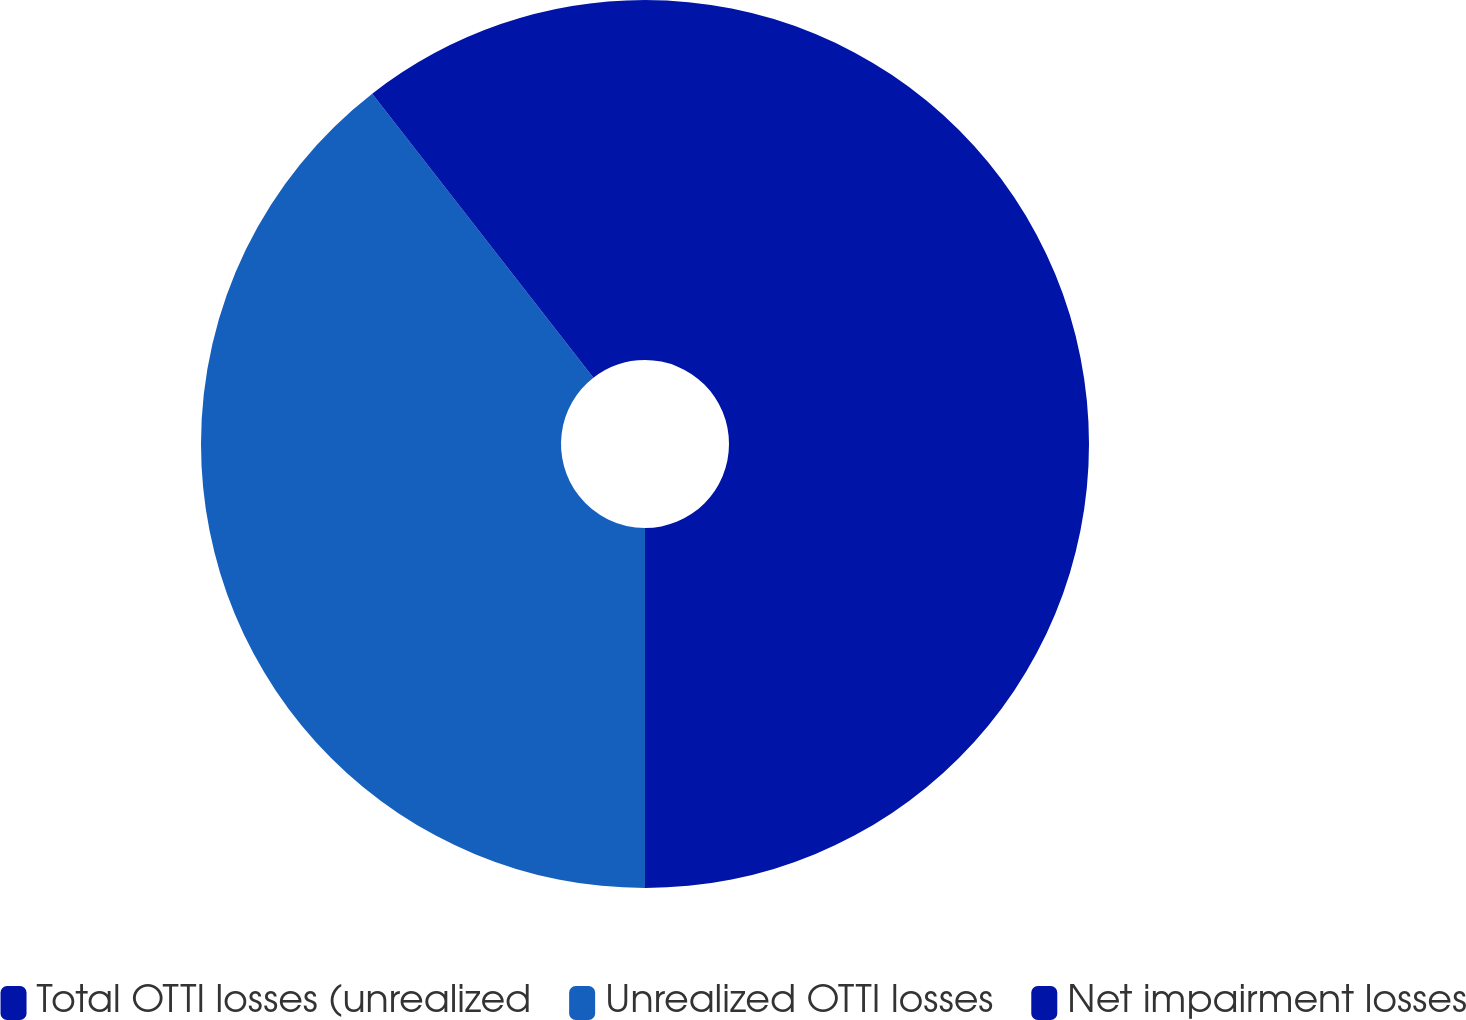Convert chart. <chart><loc_0><loc_0><loc_500><loc_500><pie_chart><fcel>Total OTTI losses (unrealized<fcel>Unrealized OTTI losses<fcel>Net impairment losses<nl><fcel>50.0%<fcel>39.47%<fcel>10.53%<nl></chart> 